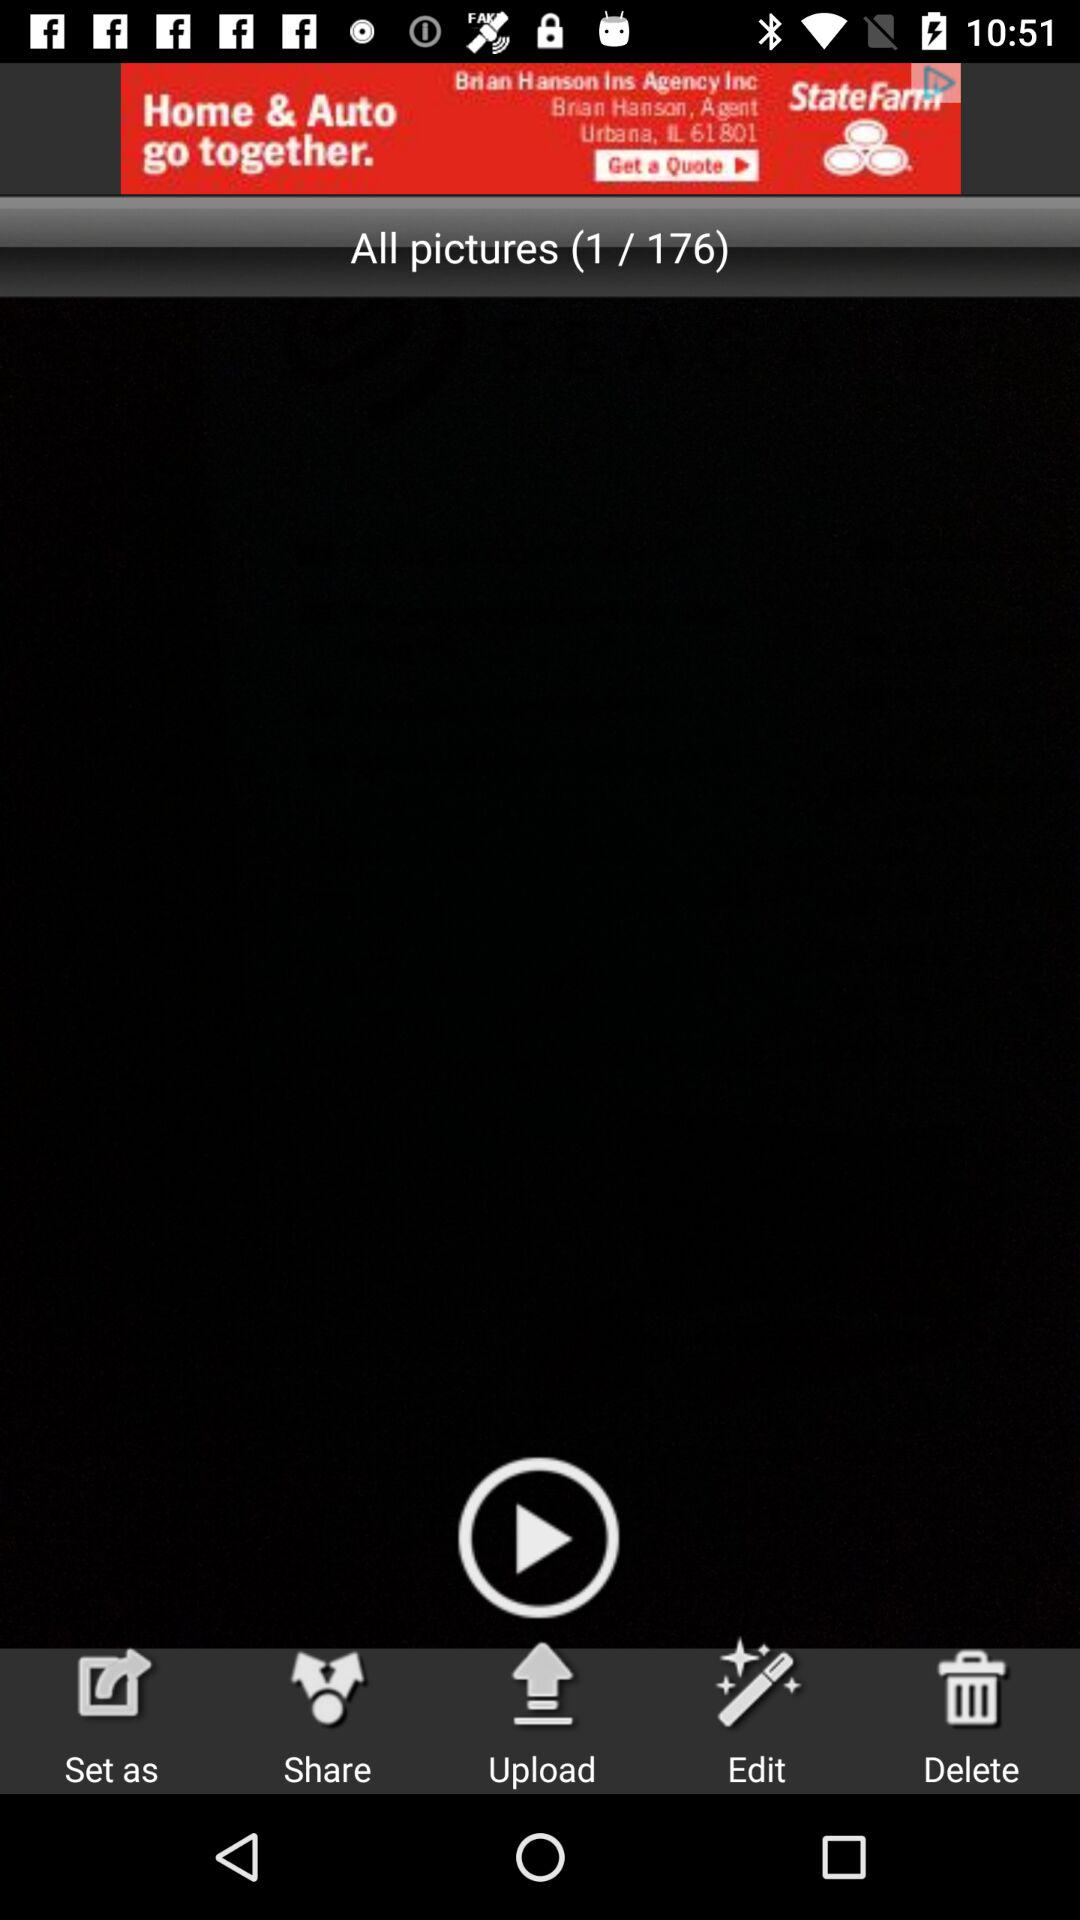How many total pictures are there? There are a total of 176 pictures. 